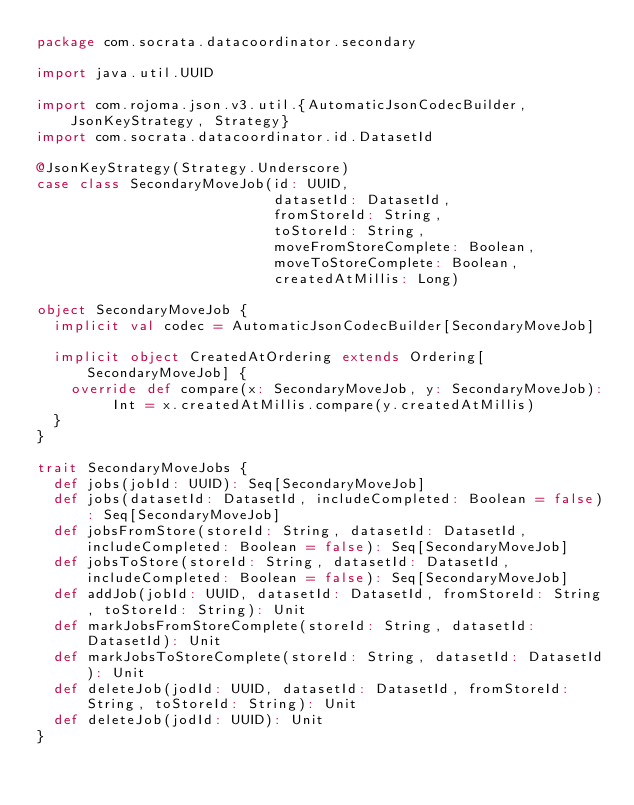Convert code to text. <code><loc_0><loc_0><loc_500><loc_500><_Scala_>package com.socrata.datacoordinator.secondary

import java.util.UUID

import com.rojoma.json.v3.util.{AutomaticJsonCodecBuilder, JsonKeyStrategy, Strategy}
import com.socrata.datacoordinator.id.DatasetId

@JsonKeyStrategy(Strategy.Underscore)
case class SecondaryMoveJob(id: UUID,
                            datasetId: DatasetId,
                            fromStoreId: String,
                            toStoreId: String,
                            moveFromStoreComplete: Boolean,
                            moveToStoreComplete: Boolean,
                            createdAtMillis: Long)

object SecondaryMoveJob {
  implicit val codec = AutomaticJsonCodecBuilder[SecondaryMoveJob]

  implicit object CreatedAtOrdering extends Ordering[SecondaryMoveJob] {
    override def compare(x: SecondaryMoveJob, y: SecondaryMoveJob): Int = x.createdAtMillis.compare(y.createdAtMillis)
  }
}

trait SecondaryMoveJobs {
  def jobs(jobId: UUID): Seq[SecondaryMoveJob]
  def jobs(datasetId: DatasetId, includeCompleted: Boolean = false): Seq[SecondaryMoveJob]
  def jobsFromStore(storeId: String, datasetId: DatasetId, includeCompleted: Boolean = false): Seq[SecondaryMoveJob]
  def jobsToStore(storeId: String, datasetId: DatasetId, includeCompleted: Boolean = false): Seq[SecondaryMoveJob]
  def addJob(jobId: UUID, datasetId: DatasetId, fromStoreId: String, toStoreId: String): Unit
  def markJobsFromStoreComplete(storeId: String, datasetId: DatasetId): Unit
  def markJobsToStoreComplete(storeId: String, datasetId: DatasetId): Unit
  def deleteJob(jodId: UUID, datasetId: DatasetId, fromStoreId: String, toStoreId: String): Unit
  def deleteJob(jodId: UUID): Unit
}</code> 